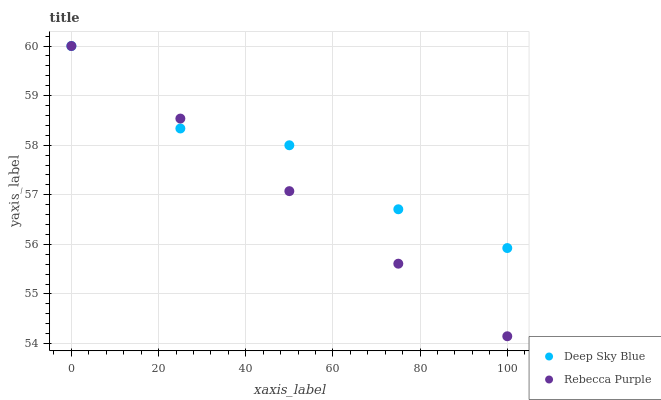Does Rebecca Purple have the minimum area under the curve?
Answer yes or no. Yes. Does Deep Sky Blue have the maximum area under the curve?
Answer yes or no. Yes. Does Deep Sky Blue have the minimum area under the curve?
Answer yes or no. No. Is Rebecca Purple the smoothest?
Answer yes or no. Yes. Is Deep Sky Blue the roughest?
Answer yes or no. Yes. Is Deep Sky Blue the smoothest?
Answer yes or no. No. Does Rebecca Purple have the lowest value?
Answer yes or no. Yes. Does Deep Sky Blue have the lowest value?
Answer yes or no. No. Does Deep Sky Blue have the highest value?
Answer yes or no. Yes. Does Rebecca Purple intersect Deep Sky Blue?
Answer yes or no. Yes. Is Rebecca Purple less than Deep Sky Blue?
Answer yes or no. No. Is Rebecca Purple greater than Deep Sky Blue?
Answer yes or no. No. 